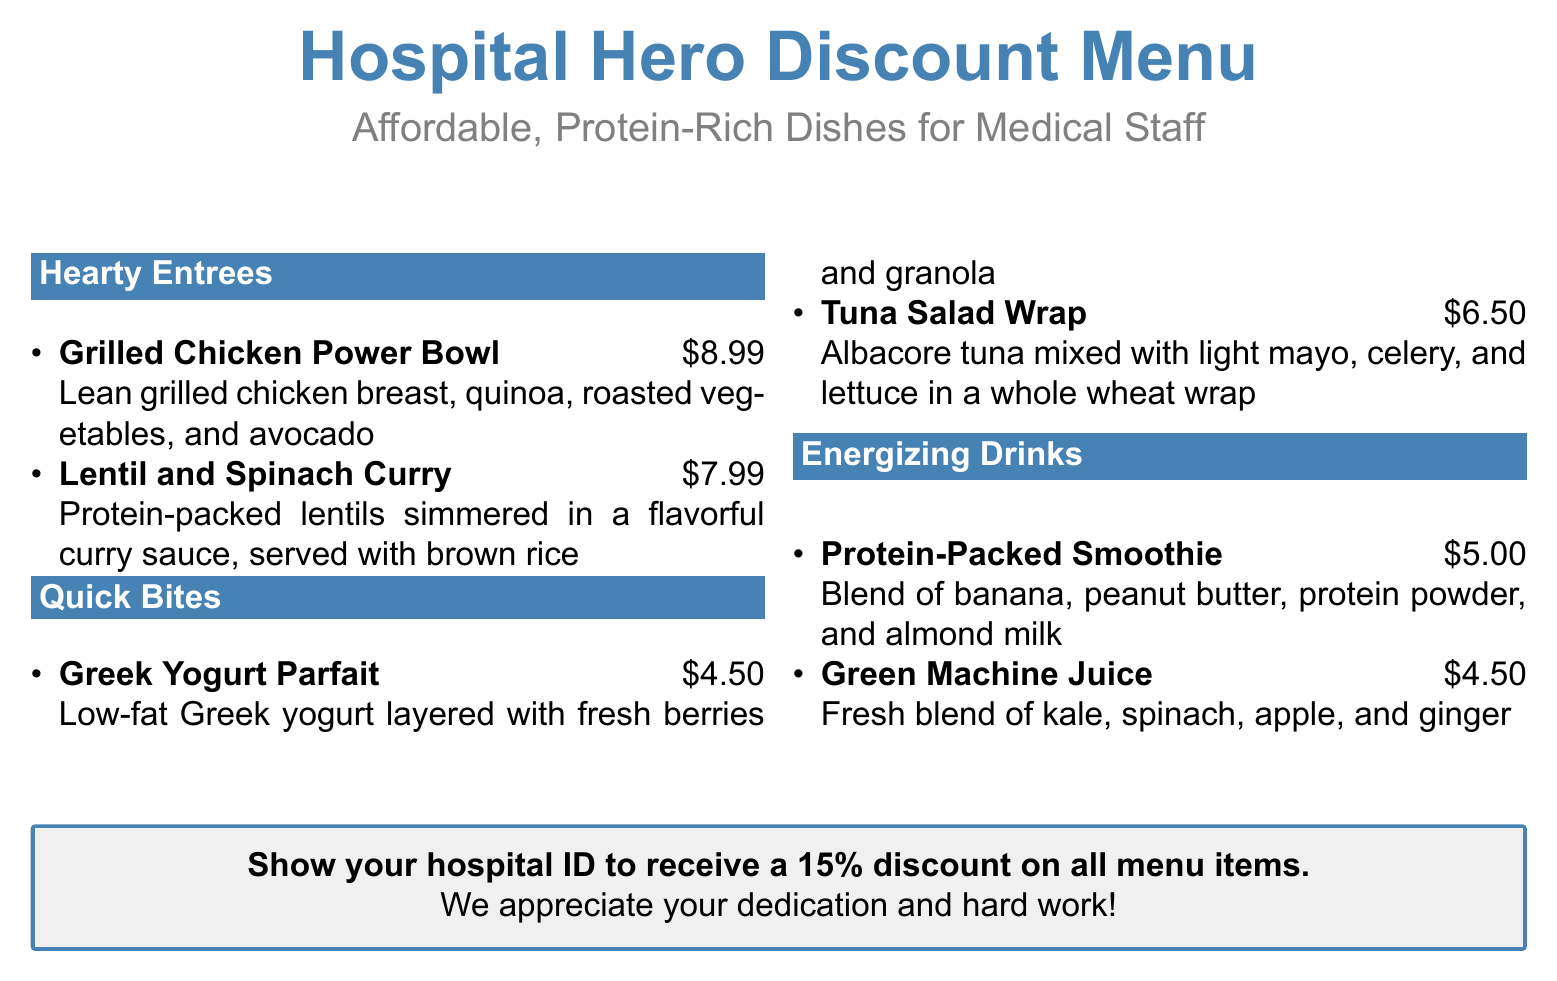What is the name of the discount menu? The title of the menu is "Hospital Hero Discount Menu."
Answer: Hospital Hero Discount Menu What is the price of the Grilled Chicken Power Bowl? The price listed for the Grilled Chicken Power Bowl is $8.99.
Answer: $8.99 Which dish is a vegetarian option? The dish that is a vegetarian option is "Lentil and Spinach Curry."
Answer: Lentil and Spinach Curry How much is the 15% discount for medical staff? The 15% discount applies to all menu items.
Answer: 15% What are the ingredients in the Protein-Packed Smoothie? The Protein-Packed Smoothie contains banana, peanut butter, protein powder, and almond milk.
Answer: Banana, peanut butter, protein powder, almond milk What is the base ingredient for the Greek Yogurt Parfait? The base ingredient for the Greek Yogurt Parfait is low-fat Greek yogurt.
Answer: Low-fat Greek yogurt Which section includes the Tuna Salad Wrap? The Tuna Salad Wrap is listed under the "Quick Bites" section.
Answer: Quick Bites What is the price of the Green Machine Juice? The price of the Green Machine Juice is $4.50.
Answer: $4.50 How many protein-rich dishes are listed in the Hearty Entrees section? There are two protein-rich dishes listed in the Hearty Entrees section.
Answer: Two 